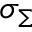<formula> <loc_0><loc_0><loc_500><loc_500>\sigma _ { \Sigma }</formula> 